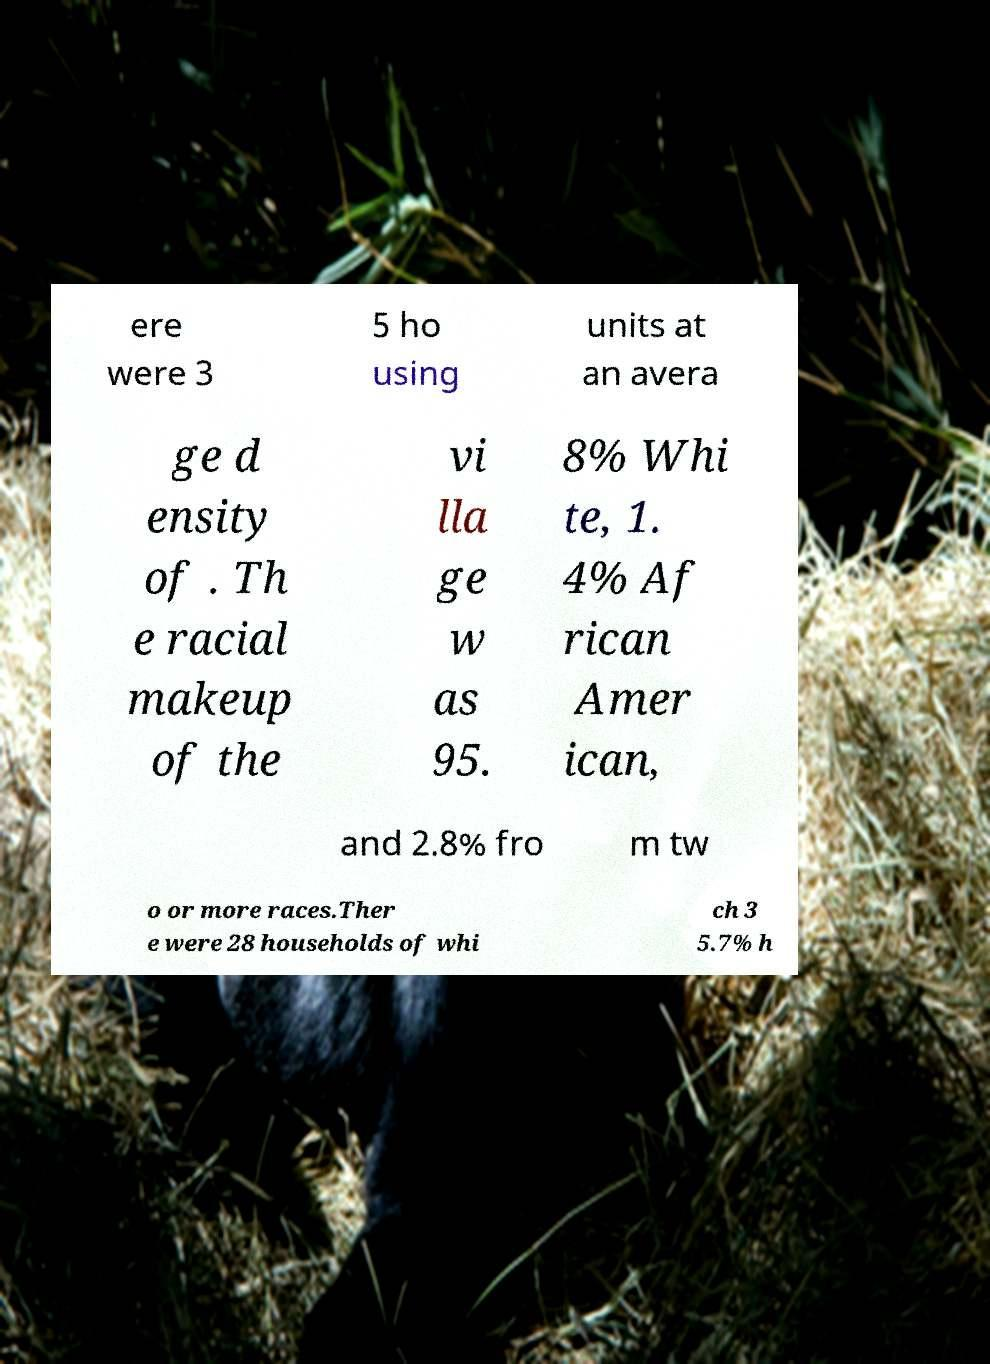Can you accurately transcribe the text from the provided image for me? ere were 3 5 ho using units at an avera ge d ensity of . Th e racial makeup of the vi lla ge w as 95. 8% Whi te, 1. 4% Af rican Amer ican, and 2.8% fro m tw o or more races.Ther e were 28 households of whi ch 3 5.7% h 